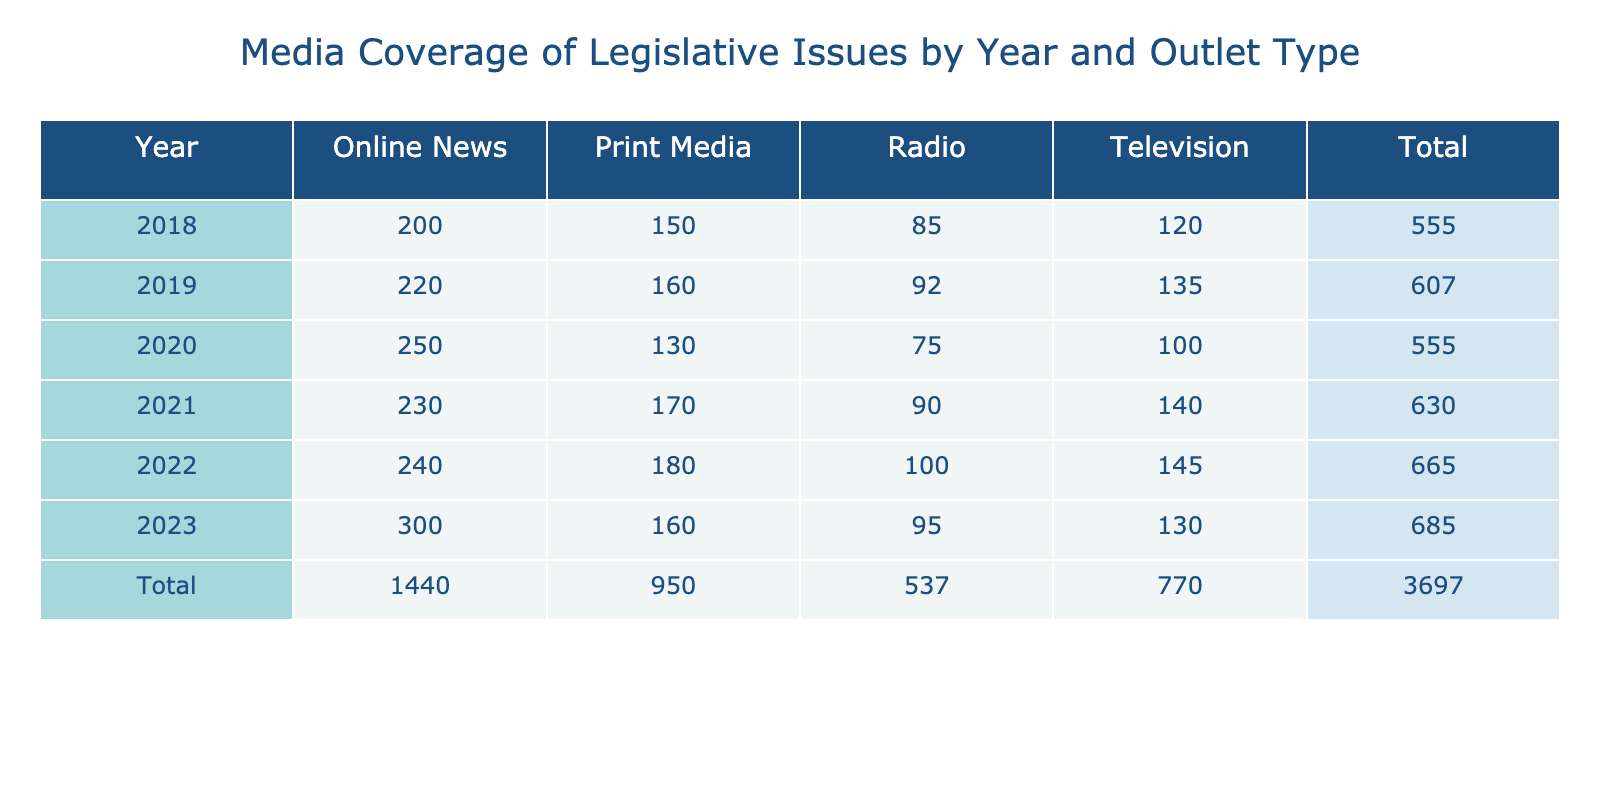What was the media coverage count for Online News in 2020? Referring to the table, for the year 2020 under the column for Online News, the count is 250.
Answer: 250 Which outlet type had the highest media coverage in 2021? In the table for 2021, Online News has the highest count at 230 compared to other outlet types.
Answer: Online News What is the total media coverage count for Print Media from 2018 to 2023? Summing the Print Media counts for the years: 150 (2018) + 160 (2019) + 130 (2020) + 170 (2021) + 180 (2022) + 160 (2023) gives a total of 1,050.
Answer: 1050 Did the media coverage for Radio increase from 2019 to 2020? Looking at the counts, Radio had 92 in 2019 and decreased to 75 in 2020, indicating a decrease.
Answer: No What was the average media coverage count for Television from 2018 to 2023? The counts for Television from 2018 to 2023 are: 120, 135, 100, 140, 145, and 130. Summing gives 970, and dividing by 6 results in an average of 161.67.
Answer: Approximately 161.67 What was the difference in media coverage between Online News in 2023 and Television in 2022? The count for Online News in 2023 is 300, while Television in 2022 has a count of 145. The difference is 300 - 145 = 155.
Answer: 155 Which year saw the lowest media coverage for Radio? In the table, the counts for Radio are: 85 (2018), 92 (2019), 75 (2020), 90 (2021), 100 (2022), and 95 (2023). The lowest count is 75 in 2020.
Answer: 2020 If we consider the total media coverage across all outlet types for 2022, what is the total? The totals for each outlet type in 2022 are: Television 145, Radio 100, Print Media 180, and Online News 240. Adding these together gives 145 + 100 + 180 + 240 = 665.
Answer: 665 Was there a consistent increase in media coverage for Online News from 2018 to 2023? The counts for Online News are: 200 (2018), 220 (2019), 250 (2020), 230 (2021), 240 (2022), and 300 (2023). Since there is a decrease from 2020 to 2021, it shows inconsistency.
Answer: No 